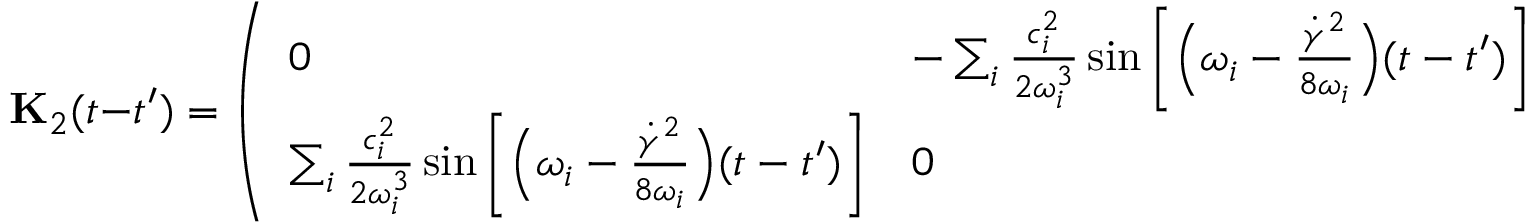<formula> <loc_0><loc_0><loc_500><loc_500>{ K } _ { 2 } ( t - t ^ { \prime } ) = \left ( \begin{array} { l l } { 0 } & { - \sum _ { i } \frac { c _ { i } ^ { 2 } } { 2 \omega _ { i } ^ { 3 } } \sin \left [ \left ( \omega _ { i } - \frac { \dot { \gamma } ^ { 2 } } { 8 \omega _ { i } } \right ) ( t - t ^ { \prime } ) \right ] } \\ { \sum _ { i } \frac { c _ { i } ^ { 2 } } { 2 \omega _ { i } ^ { 3 } } \sin \left [ \left ( \omega _ { i } - \frac { \dot { \gamma } ^ { 2 } } { 8 \omega _ { i } } \right ) ( t - t ^ { \prime } ) \right ] } & { 0 } \end{array} \right )</formula> 